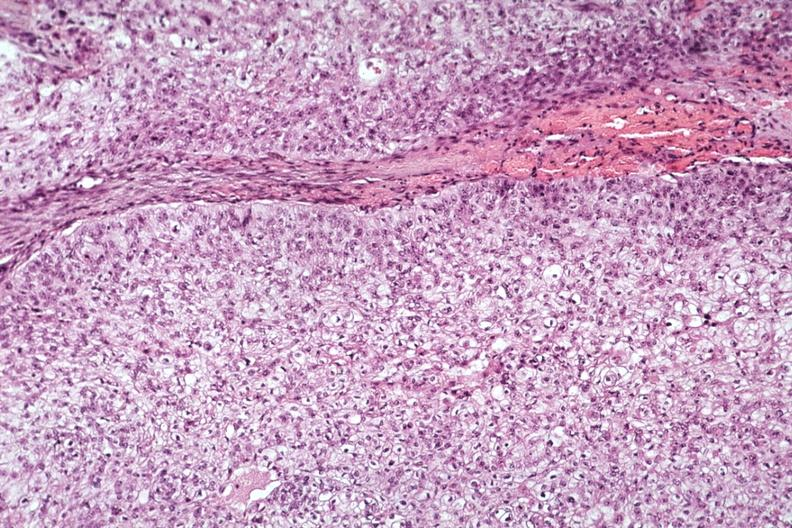s parathyroid present?
Answer the question using a single word or phrase. Yes 